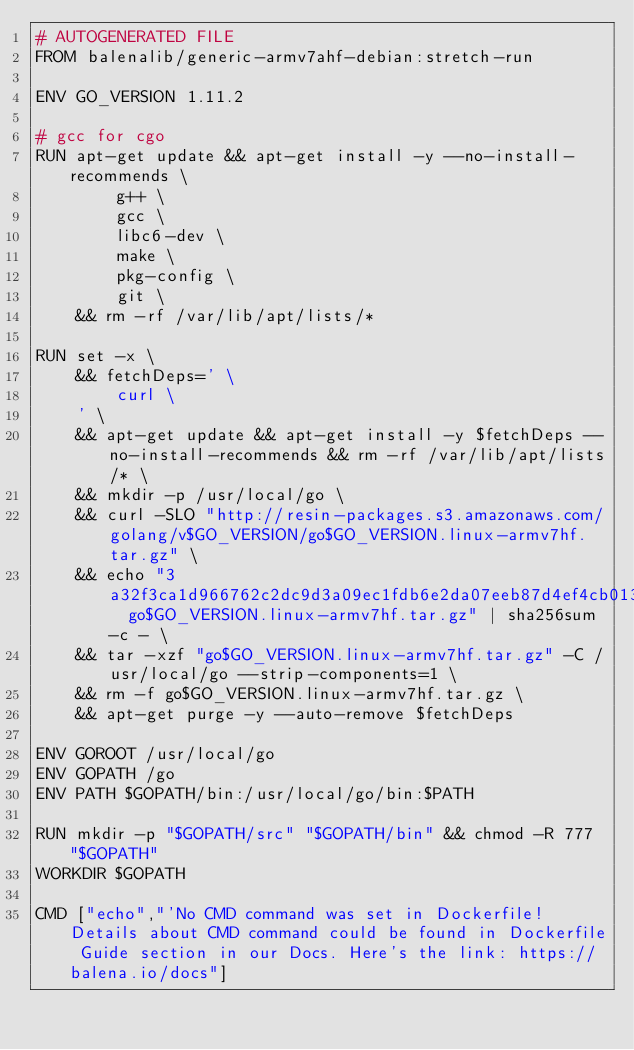Convert code to text. <code><loc_0><loc_0><loc_500><loc_500><_Dockerfile_># AUTOGENERATED FILE
FROM balenalib/generic-armv7ahf-debian:stretch-run

ENV GO_VERSION 1.11.2

# gcc for cgo
RUN apt-get update && apt-get install -y --no-install-recommends \
		g++ \
		gcc \
		libc6-dev \
		make \
		pkg-config \
		git \
	&& rm -rf /var/lib/apt/lists/*

RUN set -x \
	&& fetchDeps=' \
		curl \
	' \
	&& apt-get update && apt-get install -y $fetchDeps --no-install-recommends && rm -rf /var/lib/apt/lists/* \
	&& mkdir -p /usr/local/go \
	&& curl -SLO "http://resin-packages.s3.amazonaws.com/golang/v$GO_VERSION/go$GO_VERSION.linux-armv7hf.tar.gz" \
	&& echo "3a32f3ca1d966762c2dc9d3a09ec1fdb6e2da07eeb87d4ef4cb01362f3fa9dc8  go$GO_VERSION.linux-armv7hf.tar.gz" | sha256sum -c - \
	&& tar -xzf "go$GO_VERSION.linux-armv7hf.tar.gz" -C /usr/local/go --strip-components=1 \
	&& rm -f go$GO_VERSION.linux-armv7hf.tar.gz \
	&& apt-get purge -y --auto-remove $fetchDeps

ENV GOROOT /usr/local/go
ENV GOPATH /go
ENV PATH $GOPATH/bin:/usr/local/go/bin:$PATH

RUN mkdir -p "$GOPATH/src" "$GOPATH/bin" && chmod -R 777 "$GOPATH"
WORKDIR $GOPATH

CMD ["echo","'No CMD command was set in Dockerfile! Details about CMD command could be found in Dockerfile Guide section in our Docs. Here's the link: https://balena.io/docs"]</code> 